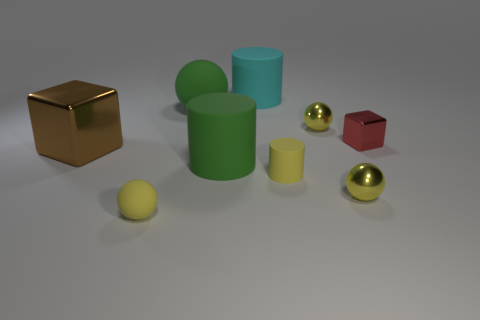Subtract all yellow balls. How many were subtracted if there are1yellow balls left? 2 Subtract all yellow blocks. How many yellow balls are left? 3 Add 1 small purple matte spheres. How many objects exist? 10 Subtract all cubes. How many objects are left? 7 Subtract 0 purple cylinders. How many objects are left? 9 Subtract all big cyan rubber cubes. Subtract all tiny yellow rubber objects. How many objects are left? 7 Add 7 big matte cylinders. How many big matte cylinders are left? 9 Add 6 large cyan rubber balls. How many large cyan rubber balls exist? 6 